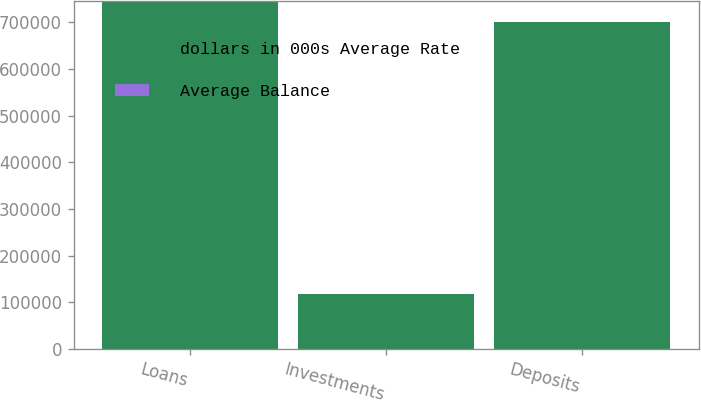<chart> <loc_0><loc_0><loc_500><loc_500><stacked_bar_chart><ecel><fcel>Loans<fcel>Investments<fcel>Deposits<nl><fcel>dollars in 000s Average Rate<fcel>746387<fcel>117350<fcel>700707<nl><fcel>Average Balance<fcel>6.8<fcel>5.25<fcel>4.59<nl></chart> 